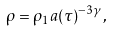<formula> <loc_0><loc_0><loc_500><loc_500>\rho = \rho _ { 1 } a ( \tau ) ^ { - 3 \gamma } ,</formula> 